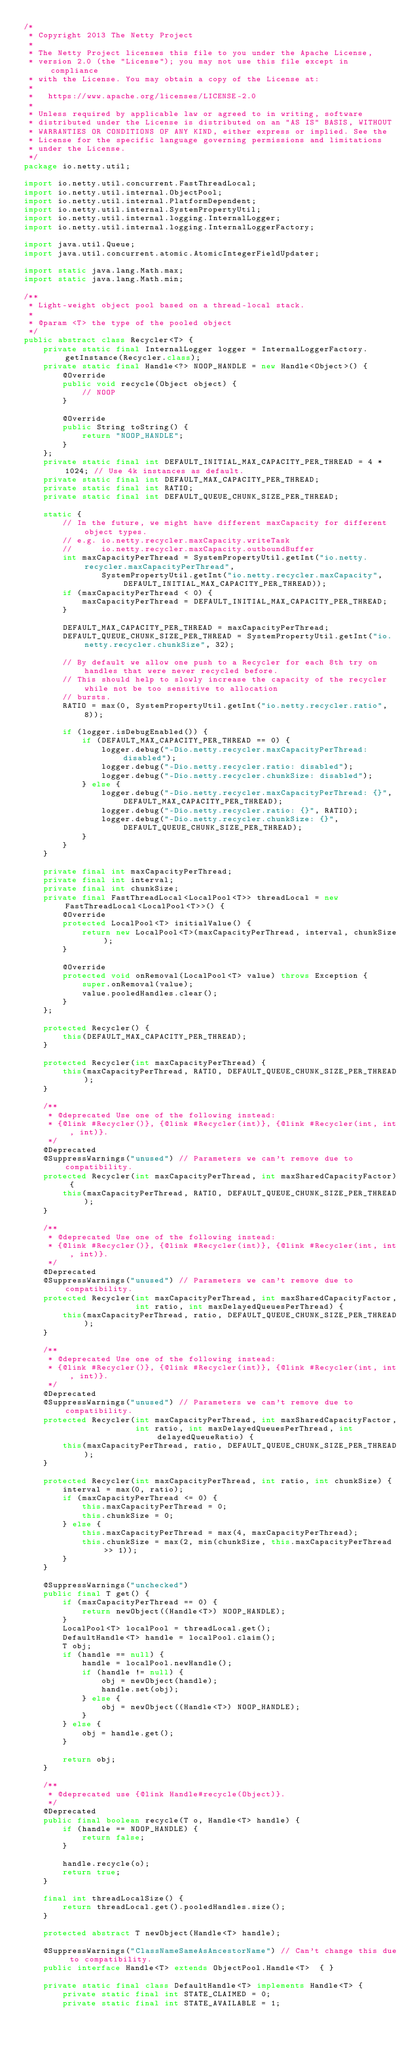<code> <loc_0><loc_0><loc_500><loc_500><_Java_>/*
 * Copyright 2013 The Netty Project
 *
 * The Netty Project licenses this file to you under the Apache License,
 * version 2.0 (the "License"); you may not use this file except in compliance
 * with the License. You may obtain a copy of the License at:
 *
 *   https://www.apache.org/licenses/LICENSE-2.0
 *
 * Unless required by applicable law or agreed to in writing, software
 * distributed under the License is distributed on an "AS IS" BASIS, WITHOUT
 * WARRANTIES OR CONDITIONS OF ANY KIND, either express or implied. See the
 * License for the specific language governing permissions and limitations
 * under the License.
 */
package io.netty.util;

import io.netty.util.concurrent.FastThreadLocal;
import io.netty.util.internal.ObjectPool;
import io.netty.util.internal.PlatformDependent;
import io.netty.util.internal.SystemPropertyUtil;
import io.netty.util.internal.logging.InternalLogger;
import io.netty.util.internal.logging.InternalLoggerFactory;

import java.util.Queue;
import java.util.concurrent.atomic.AtomicIntegerFieldUpdater;

import static java.lang.Math.max;
import static java.lang.Math.min;

/**
 * Light-weight object pool based on a thread-local stack.
 *
 * @param <T> the type of the pooled object
 */
public abstract class Recycler<T> {
    private static final InternalLogger logger = InternalLoggerFactory.getInstance(Recycler.class);
    private static final Handle<?> NOOP_HANDLE = new Handle<Object>() {
        @Override
        public void recycle(Object object) {
            // NOOP
        }

        @Override
        public String toString() {
            return "NOOP_HANDLE";
        }
    };
    private static final int DEFAULT_INITIAL_MAX_CAPACITY_PER_THREAD = 4 * 1024; // Use 4k instances as default.
    private static final int DEFAULT_MAX_CAPACITY_PER_THREAD;
    private static final int RATIO;
    private static final int DEFAULT_QUEUE_CHUNK_SIZE_PER_THREAD;

    static {
        // In the future, we might have different maxCapacity for different object types.
        // e.g. io.netty.recycler.maxCapacity.writeTask
        //      io.netty.recycler.maxCapacity.outboundBuffer
        int maxCapacityPerThread = SystemPropertyUtil.getInt("io.netty.recycler.maxCapacityPerThread",
                SystemPropertyUtil.getInt("io.netty.recycler.maxCapacity", DEFAULT_INITIAL_MAX_CAPACITY_PER_THREAD));
        if (maxCapacityPerThread < 0) {
            maxCapacityPerThread = DEFAULT_INITIAL_MAX_CAPACITY_PER_THREAD;
        }

        DEFAULT_MAX_CAPACITY_PER_THREAD = maxCapacityPerThread;
        DEFAULT_QUEUE_CHUNK_SIZE_PER_THREAD = SystemPropertyUtil.getInt("io.netty.recycler.chunkSize", 32);

        // By default we allow one push to a Recycler for each 8th try on handles that were never recycled before.
        // This should help to slowly increase the capacity of the recycler while not be too sensitive to allocation
        // bursts.
        RATIO = max(0, SystemPropertyUtil.getInt("io.netty.recycler.ratio", 8));

        if (logger.isDebugEnabled()) {
            if (DEFAULT_MAX_CAPACITY_PER_THREAD == 0) {
                logger.debug("-Dio.netty.recycler.maxCapacityPerThread: disabled");
                logger.debug("-Dio.netty.recycler.ratio: disabled");
                logger.debug("-Dio.netty.recycler.chunkSize: disabled");
            } else {
                logger.debug("-Dio.netty.recycler.maxCapacityPerThread: {}", DEFAULT_MAX_CAPACITY_PER_THREAD);
                logger.debug("-Dio.netty.recycler.ratio: {}", RATIO);
                logger.debug("-Dio.netty.recycler.chunkSize: {}", DEFAULT_QUEUE_CHUNK_SIZE_PER_THREAD);
            }
        }
    }

    private final int maxCapacityPerThread;
    private final int interval;
    private final int chunkSize;
    private final FastThreadLocal<LocalPool<T>> threadLocal = new FastThreadLocal<LocalPool<T>>() {
        @Override
        protected LocalPool<T> initialValue() {
            return new LocalPool<T>(maxCapacityPerThread, interval, chunkSize);
        }

        @Override
        protected void onRemoval(LocalPool<T> value) throws Exception {
            super.onRemoval(value);
            value.pooledHandles.clear();
        }
    };

    protected Recycler() {
        this(DEFAULT_MAX_CAPACITY_PER_THREAD);
    }

    protected Recycler(int maxCapacityPerThread) {
        this(maxCapacityPerThread, RATIO, DEFAULT_QUEUE_CHUNK_SIZE_PER_THREAD);
    }

    /**
     * @deprecated Use one of the following instead:
     * {@link #Recycler()}, {@link #Recycler(int)}, {@link #Recycler(int, int, int)}.
     */
    @Deprecated
    @SuppressWarnings("unused") // Parameters we can't remove due to compatibility.
    protected Recycler(int maxCapacityPerThread, int maxSharedCapacityFactor) {
        this(maxCapacityPerThread, RATIO, DEFAULT_QUEUE_CHUNK_SIZE_PER_THREAD);
    }

    /**
     * @deprecated Use one of the following instead:
     * {@link #Recycler()}, {@link #Recycler(int)}, {@link #Recycler(int, int, int)}.
     */
    @Deprecated
    @SuppressWarnings("unused") // Parameters we can't remove due to compatibility.
    protected Recycler(int maxCapacityPerThread, int maxSharedCapacityFactor,
                       int ratio, int maxDelayedQueuesPerThread) {
        this(maxCapacityPerThread, ratio, DEFAULT_QUEUE_CHUNK_SIZE_PER_THREAD);
    }

    /**
     * @deprecated Use one of the following instead:
     * {@link #Recycler()}, {@link #Recycler(int)}, {@link #Recycler(int, int, int)}.
     */
    @Deprecated
    @SuppressWarnings("unused") // Parameters we can't remove due to compatibility.
    protected Recycler(int maxCapacityPerThread, int maxSharedCapacityFactor,
                       int ratio, int maxDelayedQueuesPerThread, int delayedQueueRatio) {
        this(maxCapacityPerThread, ratio, DEFAULT_QUEUE_CHUNK_SIZE_PER_THREAD);
    }

    protected Recycler(int maxCapacityPerThread, int ratio, int chunkSize) {
        interval = max(0, ratio);
        if (maxCapacityPerThread <= 0) {
            this.maxCapacityPerThread = 0;
            this.chunkSize = 0;
        } else {
            this.maxCapacityPerThread = max(4, maxCapacityPerThread);
            this.chunkSize = max(2, min(chunkSize, this.maxCapacityPerThread >> 1));
        }
    }

    @SuppressWarnings("unchecked")
    public final T get() {
        if (maxCapacityPerThread == 0) {
            return newObject((Handle<T>) NOOP_HANDLE);
        }
        LocalPool<T> localPool = threadLocal.get();
        DefaultHandle<T> handle = localPool.claim();
        T obj;
        if (handle == null) {
            handle = localPool.newHandle();
            if (handle != null) {
                obj = newObject(handle);
                handle.set(obj);
            } else {
                obj = newObject((Handle<T>) NOOP_HANDLE);
            }
        } else {
            obj = handle.get();
        }

        return obj;
    }

    /**
     * @deprecated use {@link Handle#recycle(Object)}.
     */
    @Deprecated
    public final boolean recycle(T o, Handle<T> handle) {
        if (handle == NOOP_HANDLE) {
            return false;
        }

        handle.recycle(o);
        return true;
    }

    final int threadLocalSize() {
        return threadLocal.get().pooledHandles.size();
    }

    protected abstract T newObject(Handle<T> handle);

    @SuppressWarnings("ClassNameSameAsAncestorName") // Can't change this due to compatibility.
    public interface Handle<T> extends ObjectPool.Handle<T>  { }

    private static final class DefaultHandle<T> implements Handle<T> {
        private static final int STATE_CLAIMED = 0;
        private static final int STATE_AVAILABLE = 1;</code> 